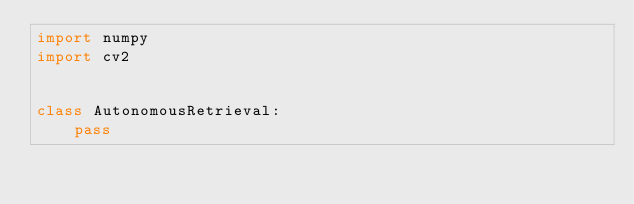Convert code to text. <code><loc_0><loc_0><loc_500><loc_500><_Python_>import numpy
import cv2


class AutonomousRetrieval:
    pass
</code> 